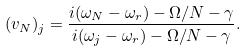<formula> <loc_0><loc_0><loc_500><loc_500>( v _ { N } ) _ { j } = \frac { i ( \omega _ { N } - \omega _ { r } ) - \Omega / N - \gamma } { i ( \omega _ { j } - \omega _ { r } ) - \Omega / N - \gamma } .</formula> 